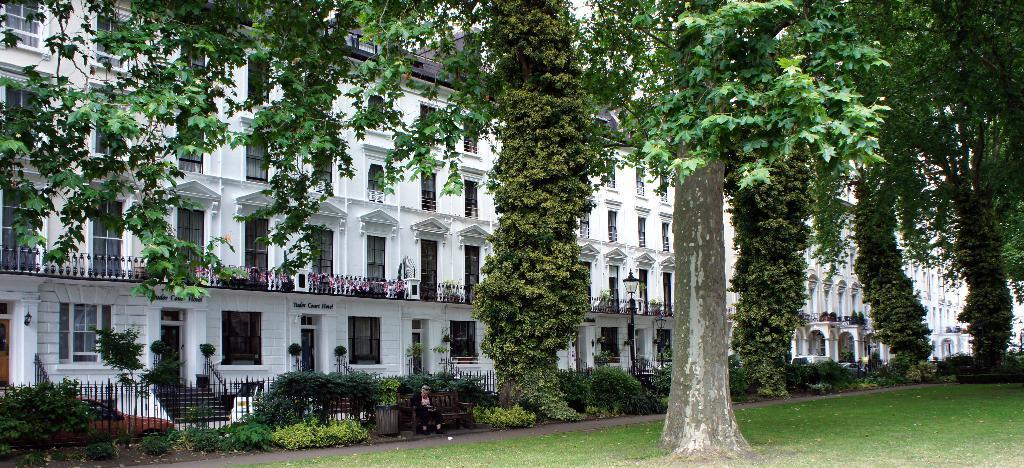Can you describe this image briefly? At the bottom of the image on the ground there is grass and also there is a tree. Behind the ground there is a road. Behind the road there are bushes, plants and a bench. On the bench there is a man sitting. Behind them there is fencing. Behind the fencing there are few cars. And also there are few trees. In the background is a building with walls, windows, doors and railings. 